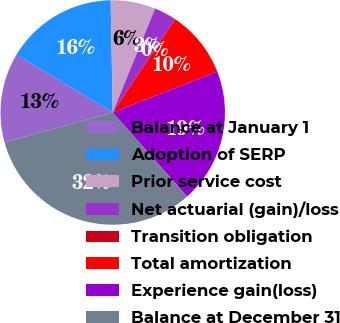<chart> <loc_0><loc_0><loc_500><loc_500><pie_chart><fcel>Balance at January 1<fcel>Adoption of SERP<fcel>Prior service cost<fcel>Net actuarial (gain)/loss<fcel>Transition obligation<fcel>Total amortization<fcel>Experience gain(loss)<fcel>Balance at December 31<nl><fcel>12.89%<fcel>16.11%<fcel>6.45%<fcel>3.23%<fcel>0.0%<fcel>9.67%<fcel>19.42%<fcel>32.23%<nl></chart> 